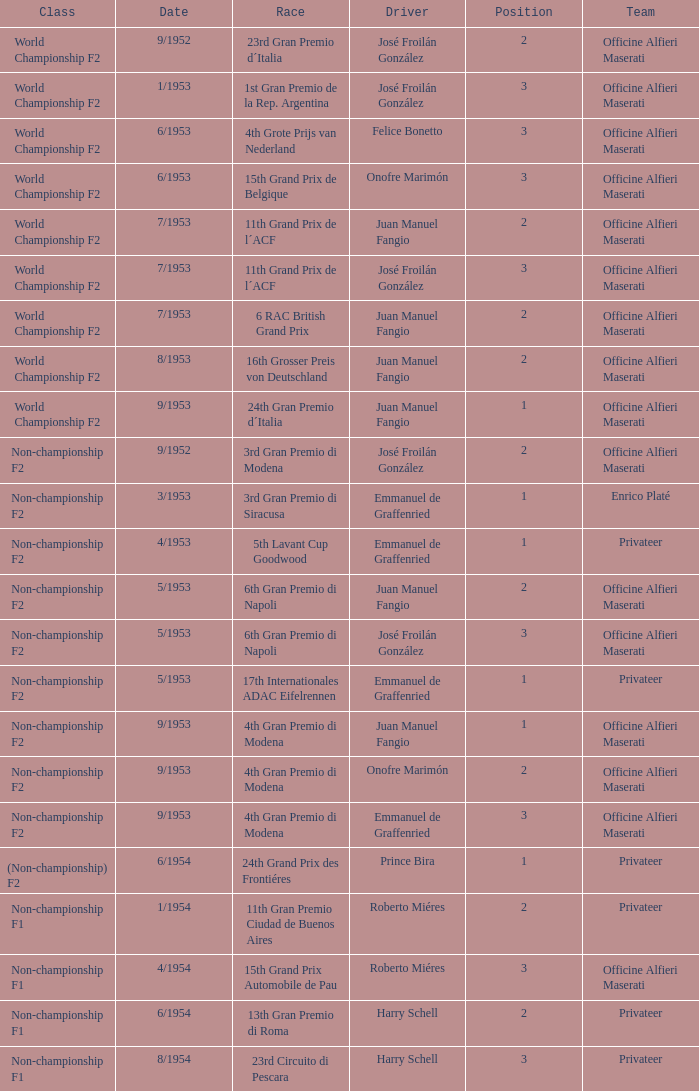What driver has a team of officine alfieri maserati and belongs to the class of non-championship f2 and has a position of 2, as well as a date of 9/1952? José Froilán González. 